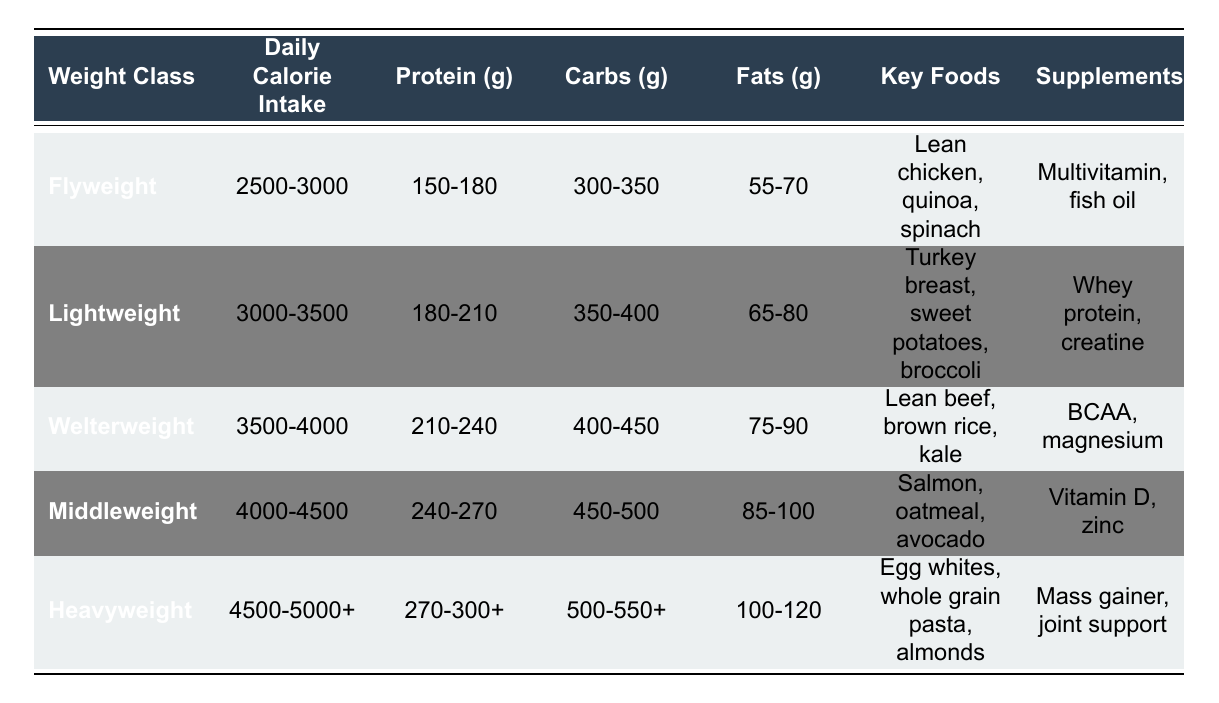What is the daily calorie intake range for the Middleweight class? The table specifically states that the Middleweight class has a daily calorie intake range between 4000 and 4500 calories.
Answer: 4000-4500 Which weight class has the highest protein intake? By comparing the protein intake values from each weight class, the Heavyweight class has a range of 270-300 grams, which is higher than that of the other classes.
Answer: Heavyweight Is Lean chicken listed as a key food for Lightweight? The table shows that Lean chicken is a key food for the Flyweight class, not for the Lightweight class, which lists Turkey breast instead.
Answer: No How many grams of carbs are recommended for the Welterweight class? The Welterweight class has a specified carbohydrate intake of 400-450 grams according to the table.
Answer: 400-450 What is the combined total of protein and fats for the Lightweight class? Adding the protein (180-210 grams) and fats (65-80 grams) gives a range of (180+65 to 210+80) which is from 245 to 290 grams in total.
Answer: 245-290 Which class requires the most daily calorie intake? By analyzing the daily calorie intake ranges, the Heavyweight class requires the highest intake, starting from 4500 calories upwards.
Answer: Heavyweight How many grams of protein does a Flyweight need at minimum? The Flyweight class requires a minimum of 150 grams of protein according to the table.
Answer: 150 grams What is the average daily calorie intake across all weight classes? The average can be calculated by taking the midpoint of each range ((2500+3000)/2, (3000+3500)/2, (3500+4000)/2, (4000+4500)/2, (4500+5000)/2). This results in an average of 3750 calories.
Answer: 3750 Do all weight classes list a supplement in their nutritional plan? Yes, the table indicates that each weight class has specific supplements recommended alongside their nutritional plans, confirming that all classes do list one.
Answer: Yes What is the highest recommended fat intake for any weight class? The Heavyweight class specifies a fat intake of 100-120 grams, which is the highest when compared to other classes.
Answer: 100-120 grams 